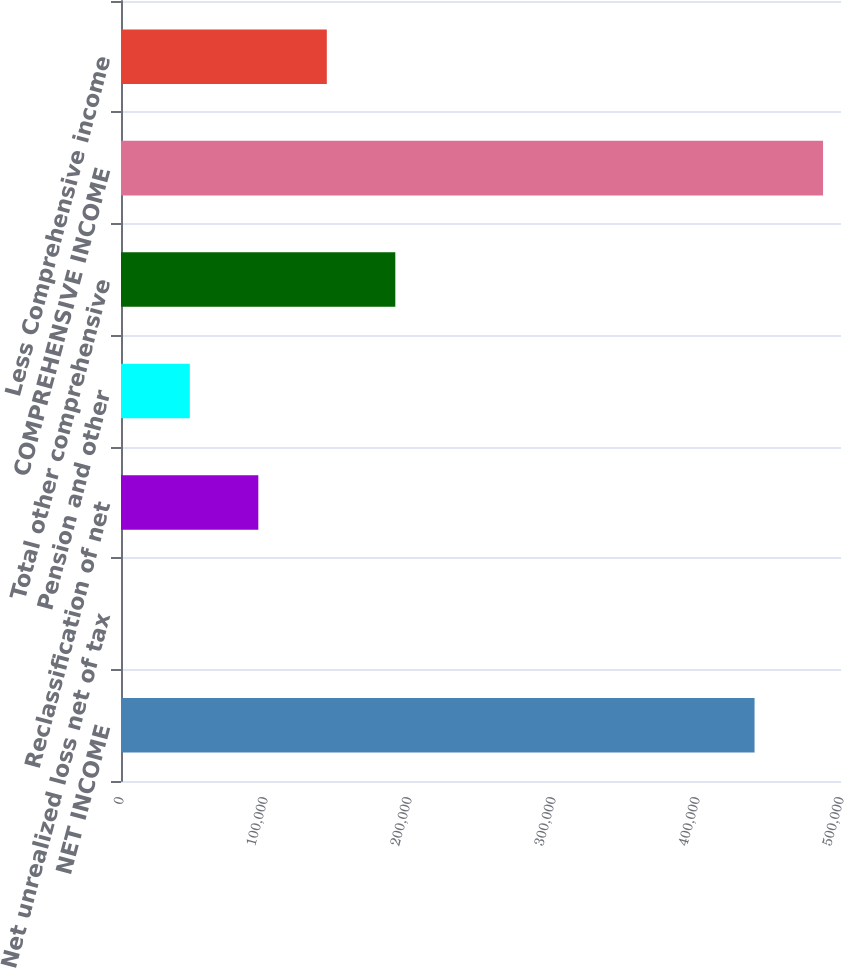<chart> <loc_0><loc_0><loc_500><loc_500><bar_chart><fcel>NET INCOME<fcel>Net unrealized loss net of tax<fcel>Reclassification of net<fcel>Pension and other<fcel>Total other comprehensive<fcel>COMPREHENSIVE INCOME<fcel>Less Comprehensive income<nl><fcel>439966<fcel>213<fcel>95354.6<fcel>47783.8<fcel>190496<fcel>487537<fcel>142925<nl></chart> 